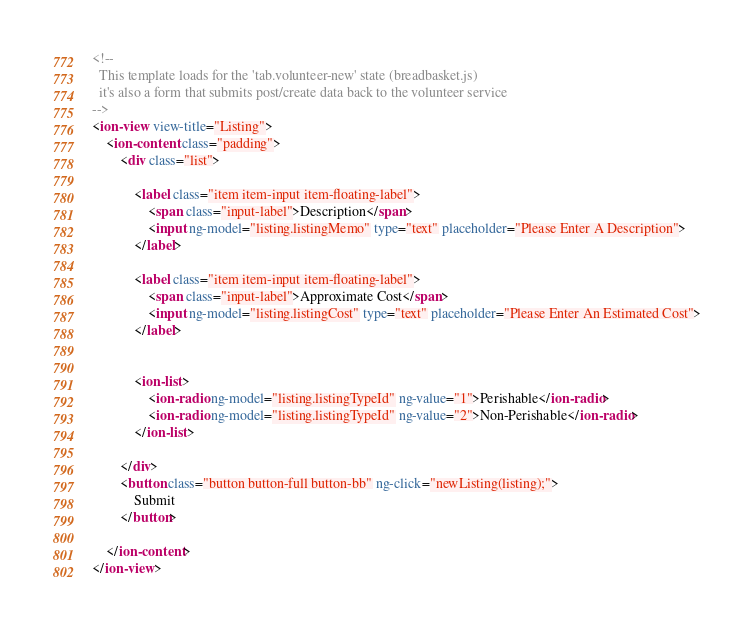<code> <loc_0><loc_0><loc_500><loc_500><_HTML_><!--
  This template loads for the 'tab.volunteer-new' state (breadbasket.js)
  it's also a form that submits post/create data back to the volunteer service
-->
<ion-view view-title="Listing">
	<ion-content class="padding">
		<div class="list">

			<label class="item item-input item-floating-label">
				<span class="input-label">Description</span>
				<input ng-model="listing.listingMemo" type="text" placeholder="Please Enter A Description">
			</label>

			<label class="item item-input item-floating-label">
				<span class="input-label">Approximate Cost</span>
				<input ng-model="listing.listingCost" type="text" placeholder="Please Enter An Estimated Cost">
			</label>


			<ion-list>
				<ion-radio ng-model="listing.listingTypeId" ng-value="1">Perishable</ion-radio>
				<ion-radio ng-model="listing.listingTypeId" ng-value="2">Non-Perishable</ion-radio>
			</ion-list>

		</div>
		<button class="button button-full button-bb" ng-click="newListing(listing);">
			Submit
		</button>

	</ion-content>
</ion-view></code> 